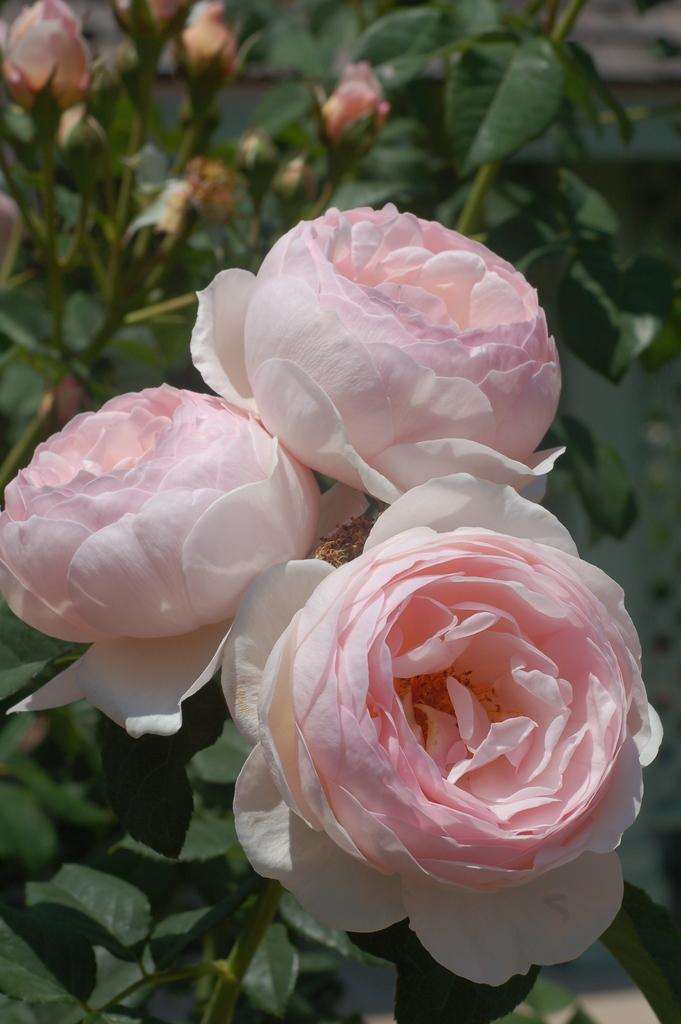What type of flowers are present in the image? There are rose flowers in the image. What parts of the flowers can be seen in the image? There are stems, leaves, and flower buds visible in the image. How is the background of the image depicted? The background has a blurred view. Are there any additional elements related to the flowers in the image? Yes, there are additional stems and leaves in the image. Can you see a kitten using its tongue to light a match in the image? No, there is no kitten or match present in the image. 